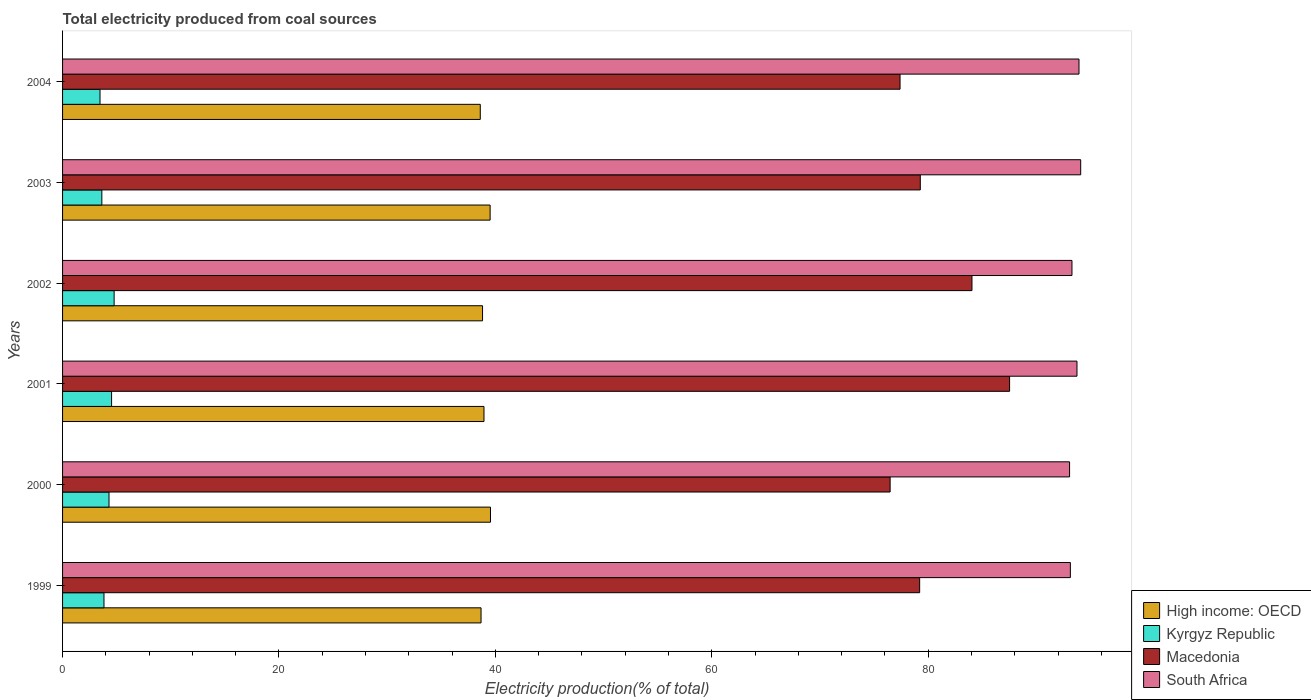Are the number of bars on each tick of the Y-axis equal?
Your response must be concise. Yes. How many bars are there on the 3rd tick from the bottom?
Ensure brevity in your answer.  4. What is the total electricity produced in Macedonia in 2003?
Offer a very short reply. 79.27. Across all years, what is the maximum total electricity produced in South Africa?
Ensure brevity in your answer.  94.09. Across all years, what is the minimum total electricity produced in High income: OECD?
Offer a terse response. 38.6. In which year was the total electricity produced in South Africa minimum?
Your answer should be compact. 2000. What is the total total electricity produced in South Africa in the graph?
Keep it short and to the point. 561.25. What is the difference between the total electricity produced in Kyrgyz Republic in 2000 and that in 2003?
Keep it short and to the point. 0.66. What is the difference between the total electricity produced in Macedonia in 2004 and the total electricity produced in Kyrgyz Republic in 2003?
Offer a terse response. 73.77. What is the average total electricity produced in South Africa per year?
Offer a terse response. 93.54. In the year 1999, what is the difference between the total electricity produced in High income: OECD and total electricity produced in South Africa?
Offer a terse response. -54.46. What is the ratio of the total electricity produced in South Africa in 2000 to that in 2002?
Ensure brevity in your answer.  1. Is the difference between the total electricity produced in High income: OECD in 1999 and 2001 greater than the difference between the total electricity produced in South Africa in 1999 and 2001?
Give a very brief answer. Yes. What is the difference between the highest and the second highest total electricity produced in High income: OECD?
Ensure brevity in your answer.  0.03. What is the difference between the highest and the lowest total electricity produced in Kyrgyz Republic?
Make the answer very short. 1.3. What does the 2nd bar from the top in 2004 represents?
Keep it short and to the point. Macedonia. What does the 2nd bar from the bottom in 1999 represents?
Give a very brief answer. Kyrgyz Republic. Are all the bars in the graph horizontal?
Your answer should be very brief. Yes. How many years are there in the graph?
Offer a terse response. 6. What is the difference between two consecutive major ticks on the X-axis?
Offer a terse response. 20. How many legend labels are there?
Your answer should be very brief. 4. How are the legend labels stacked?
Give a very brief answer. Vertical. What is the title of the graph?
Provide a succinct answer. Total electricity produced from coal sources. Does "Canada" appear as one of the legend labels in the graph?
Your answer should be compact. No. What is the label or title of the Y-axis?
Give a very brief answer. Years. What is the Electricity production(% of total) of High income: OECD in 1999?
Offer a terse response. 38.67. What is the Electricity production(% of total) in Kyrgyz Republic in 1999?
Ensure brevity in your answer.  3.83. What is the Electricity production(% of total) in Macedonia in 1999?
Keep it short and to the point. 79.21. What is the Electricity production(% of total) in South Africa in 1999?
Offer a very short reply. 93.13. What is the Electricity production(% of total) of High income: OECD in 2000?
Give a very brief answer. 39.55. What is the Electricity production(% of total) of Kyrgyz Republic in 2000?
Give a very brief answer. 4.29. What is the Electricity production(% of total) in Macedonia in 2000?
Provide a succinct answer. 76.48. What is the Electricity production(% of total) in South Africa in 2000?
Your answer should be very brief. 93.06. What is the Electricity production(% of total) of High income: OECD in 2001?
Your response must be concise. 38.95. What is the Electricity production(% of total) of Kyrgyz Republic in 2001?
Provide a short and direct response. 4.53. What is the Electricity production(% of total) in Macedonia in 2001?
Your response must be concise. 87.52. What is the Electricity production(% of total) in South Africa in 2001?
Offer a terse response. 93.75. What is the Electricity production(% of total) in High income: OECD in 2002?
Give a very brief answer. 38.81. What is the Electricity production(% of total) of Kyrgyz Republic in 2002?
Your response must be concise. 4.76. What is the Electricity production(% of total) in Macedonia in 2002?
Your answer should be compact. 84.04. What is the Electricity production(% of total) in South Africa in 2002?
Your answer should be compact. 93.28. What is the Electricity production(% of total) in High income: OECD in 2003?
Your answer should be compact. 39.51. What is the Electricity production(% of total) in Kyrgyz Republic in 2003?
Make the answer very short. 3.63. What is the Electricity production(% of total) in Macedonia in 2003?
Provide a short and direct response. 79.27. What is the Electricity production(% of total) in South Africa in 2003?
Provide a short and direct response. 94.09. What is the Electricity production(% of total) of High income: OECD in 2004?
Your answer should be very brief. 38.6. What is the Electricity production(% of total) in Kyrgyz Republic in 2004?
Ensure brevity in your answer.  3.46. What is the Electricity production(% of total) of Macedonia in 2004?
Provide a succinct answer. 77.4. What is the Electricity production(% of total) of South Africa in 2004?
Provide a short and direct response. 93.93. Across all years, what is the maximum Electricity production(% of total) in High income: OECD?
Ensure brevity in your answer.  39.55. Across all years, what is the maximum Electricity production(% of total) of Kyrgyz Republic?
Your answer should be very brief. 4.76. Across all years, what is the maximum Electricity production(% of total) of Macedonia?
Make the answer very short. 87.52. Across all years, what is the maximum Electricity production(% of total) in South Africa?
Give a very brief answer. 94.09. Across all years, what is the minimum Electricity production(% of total) in High income: OECD?
Offer a terse response. 38.6. Across all years, what is the minimum Electricity production(% of total) of Kyrgyz Republic?
Your answer should be compact. 3.46. Across all years, what is the minimum Electricity production(% of total) of Macedonia?
Ensure brevity in your answer.  76.48. Across all years, what is the minimum Electricity production(% of total) in South Africa?
Your answer should be very brief. 93.06. What is the total Electricity production(% of total) in High income: OECD in the graph?
Ensure brevity in your answer.  234.09. What is the total Electricity production(% of total) of Kyrgyz Republic in the graph?
Keep it short and to the point. 24.5. What is the total Electricity production(% of total) in Macedonia in the graph?
Keep it short and to the point. 483.91. What is the total Electricity production(% of total) of South Africa in the graph?
Offer a terse response. 561.25. What is the difference between the Electricity production(% of total) in High income: OECD in 1999 and that in 2000?
Provide a short and direct response. -0.87. What is the difference between the Electricity production(% of total) of Kyrgyz Republic in 1999 and that in 2000?
Your response must be concise. -0.47. What is the difference between the Electricity production(% of total) of Macedonia in 1999 and that in 2000?
Give a very brief answer. 2.73. What is the difference between the Electricity production(% of total) in South Africa in 1999 and that in 2000?
Give a very brief answer. 0.07. What is the difference between the Electricity production(% of total) in High income: OECD in 1999 and that in 2001?
Your response must be concise. -0.27. What is the difference between the Electricity production(% of total) of Kyrgyz Republic in 1999 and that in 2001?
Your answer should be compact. -0.7. What is the difference between the Electricity production(% of total) in Macedonia in 1999 and that in 2001?
Make the answer very short. -8.31. What is the difference between the Electricity production(% of total) in South Africa in 1999 and that in 2001?
Keep it short and to the point. -0.61. What is the difference between the Electricity production(% of total) in High income: OECD in 1999 and that in 2002?
Make the answer very short. -0.14. What is the difference between the Electricity production(% of total) of Kyrgyz Republic in 1999 and that in 2002?
Your answer should be compact. -0.94. What is the difference between the Electricity production(% of total) in Macedonia in 1999 and that in 2002?
Your response must be concise. -4.83. What is the difference between the Electricity production(% of total) in South Africa in 1999 and that in 2002?
Provide a succinct answer. -0.15. What is the difference between the Electricity production(% of total) in High income: OECD in 1999 and that in 2003?
Your answer should be very brief. -0.84. What is the difference between the Electricity production(% of total) in Kyrgyz Republic in 1999 and that in 2003?
Your response must be concise. 0.2. What is the difference between the Electricity production(% of total) in Macedonia in 1999 and that in 2003?
Your answer should be very brief. -0.06. What is the difference between the Electricity production(% of total) of South Africa in 1999 and that in 2003?
Provide a short and direct response. -0.96. What is the difference between the Electricity production(% of total) in High income: OECD in 1999 and that in 2004?
Your answer should be compact. 0.07. What is the difference between the Electricity production(% of total) in Kyrgyz Republic in 1999 and that in 2004?
Your answer should be very brief. 0.37. What is the difference between the Electricity production(% of total) of Macedonia in 1999 and that in 2004?
Your answer should be compact. 1.81. What is the difference between the Electricity production(% of total) in South Africa in 1999 and that in 2004?
Give a very brief answer. -0.8. What is the difference between the Electricity production(% of total) of High income: OECD in 2000 and that in 2001?
Give a very brief answer. 0.6. What is the difference between the Electricity production(% of total) in Kyrgyz Republic in 2000 and that in 2001?
Offer a very short reply. -0.24. What is the difference between the Electricity production(% of total) of Macedonia in 2000 and that in 2001?
Provide a succinct answer. -11.04. What is the difference between the Electricity production(% of total) in South Africa in 2000 and that in 2001?
Provide a succinct answer. -0.68. What is the difference between the Electricity production(% of total) of High income: OECD in 2000 and that in 2002?
Ensure brevity in your answer.  0.73. What is the difference between the Electricity production(% of total) in Kyrgyz Republic in 2000 and that in 2002?
Make the answer very short. -0.47. What is the difference between the Electricity production(% of total) in Macedonia in 2000 and that in 2002?
Keep it short and to the point. -7.56. What is the difference between the Electricity production(% of total) of South Africa in 2000 and that in 2002?
Keep it short and to the point. -0.22. What is the difference between the Electricity production(% of total) in High income: OECD in 2000 and that in 2003?
Give a very brief answer. 0.03. What is the difference between the Electricity production(% of total) in Kyrgyz Republic in 2000 and that in 2003?
Make the answer very short. 0.66. What is the difference between the Electricity production(% of total) in Macedonia in 2000 and that in 2003?
Your response must be concise. -2.79. What is the difference between the Electricity production(% of total) of South Africa in 2000 and that in 2003?
Your answer should be very brief. -1.03. What is the difference between the Electricity production(% of total) of High income: OECD in 2000 and that in 2004?
Provide a succinct answer. 0.94. What is the difference between the Electricity production(% of total) in Kyrgyz Republic in 2000 and that in 2004?
Ensure brevity in your answer.  0.83. What is the difference between the Electricity production(% of total) in Macedonia in 2000 and that in 2004?
Keep it short and to the point. -0.92. What is the difference between the Electricity production(% of total) in South Africa in 2000 and that in 2004?
Your answer should be very brief. -0.87. What is the difference between the Electricity production(% of total) in High income: OECD in 2001 and that in 2002?
Provide a short and direct response. 0.13. What is the difference between the Electricity production(% of total) of Kyrgyz Republic in 2001 and that in 2002?
Make the answer very short. -0.24. What is the difference between the Electricity production(% of total) of Macedonia in 2001 and that in 2002?
Your response must be concise. 3.48. What is the difference between the Electricity production(% of total) in South Africa in 2001 and that in 2002?
Give a very brief answer. 0.46. What is the difference between the Electricity production(% of total) of High income: OECD in 2001 and that in 2003?
Make the answer very short. -0.57. What is the difference between the Electricity production(% of total) in Kyrgyz Republic in 2001 and that in 2003?
Make the answer very short. 0.9. What is the difference between the Electricity production(% of total) in Macedonia in 2001 and that in 2003?
Keep it short and to the point. 8.25. What is the difference between the Electricity production(% of total) in South Africa in 2001 and that in 2003?
Give a very brief answer. -0.34. What is the difference between the Electricity production(% of total) of High income: OECD in 2001 and that in 2004?
Provide a succinct answer. 0.34. What is the difference between the Electricity production(% of total) in Kyrgyz Republic in 2001 and that in 2004?
Your answer should be compact. 1.07. What is the difference between the Electricity production(% of total) in Macedonia in 2001 and that in 2004?
Your answer should be very brief. 10.12. What is the difference between the Electricity production(% of total) in South Africa in 2001 and that in 2004?
Give a very brief answer. -0.19. What is the difference between the Electricity production(% of total) in High income: OECD in 2002 and that in 2003?
Provide a short and direct response. -0.7. What is the difference between the Electricity production(% of total) in Kyrgyz Republic in 2002 and that in 2003?
Keep it short and to the point. 1.13. What is the difference between the Electricity production(% of total) in Macedonia in 2002 and that in 2003?
Offer a terse response. 4.78. What is the difference between the Electricity production(% of total) in South Africa in 2002 and that in 2003?
Make the answer very short. -0.81. What is the difference between the Electricity production(% of total) of High income: OECD in 2002 and that in 2004?
Offer a very short reply. 0.21. What is the difference between the Electricity production(% of total) of Kyrgyz Republic in 2002 and that in 2004?
Provide a short and direct response. 1.3. What is the difference between the Electricity production(% of total) of Macedonia in 2002 and that in 2004?
Keep it short and to the point. 6.65. What is the difference between the Electricity production(% of total) in South Africa in 2002 and that in 2004?
Your answer should be compact. -0.65. What is the difference between the Electricity production(% of total) of High income: OECD in 2003 and that in 2004?
Your answer should be compact. 0.91. What is the difference between the Electricity production(% of total) of Kyrgyz Republic in 2003 and that in 2004?
Provide a succinct answer. 0.17. What is the difference between the Electricity production(% of total) in Macedonia in 2003 and that in 2004?
Your answer should be very brief. 1.87. What is the difference between the Electricity production(% of total) of South Africa in 2003 and that in 2004?
Provide a succinct answer. 0.16. What is the difference between the Electricity production(% of total) in High income: OECD in 1999 and the Electricity production(% of total) in Kyrgyz Republic in 2000?
Your answer should be compact. 34.38. What is the difference between the Electricity production(% of total) in High income: OECD in 1999 and the Electricity production(% of total) in Macedonia in 2000?
Keep it short and to the point. -37.81. What is the difference between the Electricity production(% of total) of High income: OECD in 1999 and the Electricity production(% of total) of South Africa in 2000?
Provide a succinct answer. -54.39. What is the difference between the Electricity production(% of total) in Kyrgyz Republic in 1999 and the Electricity production(% of total) in Macedonia in 2000?
Give a very brief answer. -72.65. What is the difference between the Electricity production(% of total) in Kyrgyz Republic in 1999 and the Electricity production(% of total) in South Africa in 2000?
Offer a very short reply. -89.24. What is the difference between the Electricity production(% of total) of Macedonia in 1999 and the Electricity production(% of total) of South Africa in 2000?
Your answer should be compact. -13.86. What is the difference between the Electricity production(% of total) of High income: OECD in 1999 and the Electricity production(% of total) of Kyrgyz Republic in 2001?
Offer a terse response. 34.14. What is the difference between the Electricity production(% of total) of High income: OECD in 1999 and the Electricity production(% of total) of Macedonia in 2001?
Make the answer very short. -48.85. What is the difference between the Electricity production(% of total) in High income: OECD in 1999 and the Electricity production(% of total) in South Africa in 2001?
Your answer should be very brief. -55.07. What is the difference between the Electricity production(% of total) in Kyrgyz Republic in 1999 and the Electricity production(% of total) in Macedonia in 2001?
Make the answer very short. -83.69. What is the difference between the Electricity production(% of total) of Kyrgyz Republic in 1999 and the Electricity production(% of total) of South Africa in 2001?
Ensure brevity in your answer.  -89.92. What is the difference between the Electricity production(% of total) of Macedonia in 1999 and the Electricity production(% of total) of South Africa in 2001?
Offer a very short reply. -14.54. What is the difference between the Electricity production(% of total) in High income: OECD in 1999 and the Electricity production(% of total) in Kyrgyz Republic in 2002?
Your answer should be compact. 33.91. What is the difference between the Electricity production(% of total) in High income: OECD in 1999 and the Electricity production(% of total) in Macedonia in 2002?
Your response must be concise. -45.37. What is the difference between the Electricity production(% of total) of High income: OECD in 1999 and the Electricity production(% of total) of South Africa in 2002?
Provide a succinct answer. -54.61. What is the difference between the Electricity production(% of total) in Kyrgyz Republic in 1999 and the Electricity production(% of total) in Macedonia in 2002?
Your answer should be very brief. -80.21. What is the difference between the Electricity production(% of total) of Kyrgyz Republic in 1999 and the Electricity production(% of total) of South Africa in 2002?
Offer a very short reply. -89.46. What is the difference between the Electricity production(% of total) in Macedonia in 1999 and the Electricity production(% of total) in South Africa in 2002?
Your answer should be very brief. -14.08. What is the difference between the Electricity production(% of total) of High income: OECD in 1999 and the Electricity production(% of total) of Kyrgyz Republic in 2003?
Your response must be concise. 35.04. What is the difference between the Electricity production(% of total) of High income: OECD in 1999 and the Electricity production(% of total) of Macedonia in 2003?
Ensure brevity in your answer.  -40.59. What is the difference between the Electricity production(% of total) in High income: OECD in 1999 and the Electricity production(% of total) in South Africa in 2003?
Your response must be concise. -55.42. What is the difference between the Electricity production(% of total) in Kyrgyz Republic in 1999 and the Electricity production(% of total) in Macedonia in 2003?
Your answer should be compact. -75.44. What is the difference between the Electricity production(% of total) of Kyrgyz Republic in 1999 and the Electricity production(% of total) of South Africa in 2003?
Your response must be concise. -90.26. What is the difference between the Electricity production(% of total) of Macedonia in 1999 and the Electricity production(% of total) of South Africa in 2003?
Offer a terse response. -14.88. What is the difference between the Electricity production(% of total) in High income: OECD in 1999 and the Electricity production(% of total) in Kyrgyz Republic in 2004?
Make the answer very short. 35.21. What is the difference between the Electricity production(% of total) in High income: OECD in 1999 and the Electricity production(% of total) in Macedonia in 2004?
Provide a short and direct response. -38.72. What is the difference between the Electricity production(% of total) in High income: OECD in 1999 and the Electricity production(% of total) in South Africa in 2004?
Keep it short and to the point. -55.26. What is the difference between the Electricity production(% of total) in Kyrgyz Republic in 1999 and the Electricity production(% of total) in Macedonia in 2004?
Your response must be concise. -73.57. What is the difference between the Electricity production(% of total) of Kyrgyz Republic in 1999 and the Electricity production(% of total) of South Africa in 2004?
Your response must be concise. -90.11. What is the difference between the Electricity production(% of total) in Macedonia in 1999 and the Electricity production(% of total) in South Africa in 2004?
Give a very brief answer. -14.73. What is the difference between the Electricity production(% of total) in High income: OECD in 2000 and the Electricity production(% of total) in Kyrgyz Republic in 2001?
Your response must be concise. 35.02. What is the difference between the Electricity production(% of total) in High income: OECD in 2000 and the Electricity production(% of total) in Macedonia in 2001?
Offer a very short reply. -47.97. What is the difference between the Electricity production(% of total) of High income: OECD in 2000 and the Electricity production(% of total) of South Africa in 2001?
Offer a very short reply. -54.2. What is the difference between the Electricity production(% of total) of Kyrgyz Republic in 2000 and the Electricity production(% of total) of Macedonia in 2001?
Offer a terse response. -83.23. What is the difference between the Electricity production(% of total) of Kyrgyz Republic in 2000 and the Electricity production(% of total) of South Africa in 2001?
Your response must be concise. -89.45. What is the difference between the Electricity production(% of total) of Macedonia in 2000 and the Electricity production(% of total) of South Africa in 2001?
Your answer should be compact. -17.27. What is the difference between the Electricity production(% of total) in High income: OECD in 2000 and the Electricity production(% of total) in Kyrgyz Republic in 2002?
Offer a terse response. 34.78. What is the difference between the Electricity production(% of total) in High income: OECD in 2000 and the Electricity production(% of total) in Macedonia in 2002?
Your answer should be very brief. -44.5. What is the difference between the Electricity production(% of total) in High income: OECD in 2000 and the Electricity production(% of total) in South Africa in 2002?
Your answer should be very brief. -53.74. What is the difference between the Electricity production(% of total) in Kyrgyz Republic in 2000 and the Electricity production(% of total) in Macedonia in 2002?
Ensure brevity in your answer.  -79.75. What is the difference between the Electricity production(% of total) of Kyrgyz Republic in 2000 and the Electricity production(% of total) of South Africa in 2002?
Offer a very short reply. -88.99. What is the difference between the Electricity production(% of total) of Macedonia in 2000 and the Electricity production(% of total) of South Africa in 2002?
Ensure brevity in your answer.  -16.8. What is the difference between the Electricity production(% of total) in High income: OECD in 2000 and the Electricity production(% of total) in Kyrgyz Republic in 2003?
Provide a succinct answer. 35.92. What is the difference between the Electricity production(% of total) in High income: OECD in 2000 and the Electricity production(% of total) in Macedonia in 2003?
Make the answer very short. -39.72. What is the difference between the Electricity production(% of total) in High income: OECD in 2000 and the Electricity production(% of total) in South Africa in 2003?
Your answer should be compact. -54.54. What is the difference between the Electricity production(% of total) in Kyrgyz Republic in 2000 and the Electricity production(% of total) in Macedonia in 2003?
Offer a terse response. -74.97. What is the difference between the Electricity production(% of total) of Kyrgyz Republic in 2000 and the Electricity production(% of total) of South Africa in 2003?
Give a very brief answer. -89.8. What is the difference between the Electricity production(% of total) of Macedonia in 2000 and the Electricity production(% of total) of South Africa in 2003?
Give a very brief answer. -17.61. What is the difference between the Electricity production(% of total) of High income: OECD in 2000 and the Electricity production(% of total) of Kyrgyz Republic in 2004?
Make the answer very short. 36.08. What is the difference between the Electricity production(% of total) in High income: OECD in 2000 and the Electricity production(% of total) in Macedonia in 2004?
Ensure brevity in your answer.  -37.85. What is the difference between the Electricity production(% of total) in High income: OECD in 2000 and the Electricity production(% of total) in South Africa in 2004?
Provide a succinct answer. -54.39. What is the difference between the Electricity production(% of total) of Kyrgyz Republic in 2000 and the Electricity production(% of total) of Macedonia in 2004?
Provide a succinct answer. -73.1. What is the difference between the Electricity production(% of total) in Kyrgyz Republic in 2000 and the Electricity production(% of total) in South Africa in 2004?
Offer a very short reply. -89.64. What is the difference between the Electricity production(% of total) of Macedonia in 2000 and the Electricity production(% of total) of South Africa in 2004?
Your response must be concise. -17.45. What is the difference between the Electricity production(% of total) in High income: OECD in 2001 and the Electricity production(% of total) in Kyrgyz Republic in 2002?
Keep it short and to the point. 34.18. What is the difference between the Electricity production(% of total) in High income: OECD in 2001 and the Electricity production(% of total) in Macedonia in 2002?
Offer a very short reply. -45.1. What is the difference between the Electricity production(% of total) in High income: OECD in 2001 and the Electricity production(% of total) in South Africa in 2002?
Give a very brief answer. -54.34. What is the difference between the Electricity production(% of total) in Kyrgyz Republic in 2001 and the Electricity production(% of total) in Macedonia in 2002?
Provide a succinct answer. -79.51. What is the difference between the Electricity production(% of total) in Kyrgyz Republic in 2001 and the Electricity production(% of total) in South Africa in 2002?
Keep it short and to the point. -88.75. What is the difference between the Electricity production(% of total) of Macedonia in 2001 and the Electricity production(% of total) of South Africa in 2002?
Your answer should be very brief. -5.76. What is the difference between the Electricity production(% of total) of High income: OECD in 2001 and the Electricity production(% of total) of Kyrgyz Republic in 2003?
Provide a succinct answer. 35.32. What is the difference between the Electricity production(% of total) in High income: OECD in 2001 and the Electricity production(% of total) in Macedonia in 2003?
Ensure brevity in your answer.  -40.32. What is the difference between the Electricity production(% of total) of High income: OECD in 2001 and the Electricity production(% of total) of South Africa in 2003?
Offer a terse response. -55.14. What is the difference between the Electricity production(% of total) of Kyrgyz Republic in 2001 and the Electricity production(% of total) of Macedonia in 2003?
Your response must be concise. -74.74. What is the difference between the Electricity production(% of total) in Kyrgyz Republic in 2001 and the Electricity production(% of total) in South Africa in 2003?
Give a very brief answer. -89.56. What is the difference between the Electricity production(% of total) in Macedonia in 2001 and the Electricity production(% of total) in South Africa in 2003?
Ensure brevity in your answer.  -6.57. What is the difference between the Electricity production(% of total) of High income: OECD in 2001 and the Electricity production(% of total) of Kyrgyz Republic in 2004?
Offer a terse response. 35.48. What is the difference between the Electricity production(% of total) in High income: OECD in 2001 and the Electricity production(% of total) in Macedonia in 2004?
Your answer should be very brief. -38.45. What is the difference between the Electricity production(% of total) in High income: OECD in 2001 and the Electricity production(% of total) in South Africa in 2004?
Your answer should be very brief. -54.99. What is the difference between the Electricity production(% of total) in Kyrgyz Republic in 2001 and the Electricity production(% of total) in Macedonia in 2004?
Give a very brief answer. -72.87. What is the difference between the Electricity production(% of total) of Kyrgyz Republic in 2001 and the Electricity production(% of total) of South Africa in 2004?
Give a very brief answer. -89.4. What is the difference between the Electricity production(% of total) in Macedonia in 2001 and the Electricity production(% of total) in South Africa in 2004?
Offer a terse response. -6.41. What is the difference between the Electricity production(% of total) of High income: OECD in 2002 and the Electricity production(% of total) of Kyrgyz Republic in 2003?
Give a very brief answer. 35.18. What is the difference between the Electricity production(% of total) in High income: OECD in 2002 and the Electricity production(% of total) in Macedonia in 2003?
Your answer should be very brief. -40.45. What is the difference between the Electricity production(% of total) of High income: OECD in 2002 and the Electricity production(% of total) of South Africa in 2003?
Provide a succinct answer. -55.28. What is the difference between the Electricity production(% of total) in Kyrgyz Republic in 2002 and the Electricity production(% of total) in Macedonia in 2003?
Your answer should be very brief. -74.5. What is the difference between the Electricity production(% of total) in Kyrgyz Republic in 2002 and the Electricity production(% of total) in South Africa in 2003?
Offer a very short reply. -89.33. What is the difference between the Electricity production(% of total) of Macedonia in 2002 and the Electricity production(% of total) of South Africa in 2003?
Keep it short and to the point. -10.05. What is the difference between the Electricity production(% of total) of High income: OECD in 2002 and the Electricity production(% of total) of Kyrgyz Republic in 2004?
Provide a short and direct response. 35.35. What is the difference between the Electricity production(% of total) in High income: OECD in 2002 and the Electricity production(% of total) in Macedonia in 2004?
Make the answer very short. -38.58. What is the difference between the Electricity production(% of total) of High income: OECD in 2002 and the Electricity production(% of total) of South Africa in 2004?
Provide a succinct answer. -55.12. What is the difference between the Electricity production(% of total) in Kyrgyz Republic in 2002 and the Electricity production(% of total) in Macedonia in 2004?
Offer a very short reply. -72.63. What is the difference between the Electricity production(% of total) in Kyrgyz Republic in 2002 and the Electricity production(% of total) in South Africa in 2004?
Offer a very short reply. -89.17. What is the difference between the Electricity production(% of total) of Macedonia in 2002 and the Electricity production(% of total) of South Africa in 2004?
Offer a terse response. -9.89. What is the difference between the Electricity production(% of total) in High income: OECD in 2003 and the Electricity production(% of total) in Kyrgyz Republic in 2004?
Provide a short and direct response. 36.05. What is the difference between the Electricity production(% of total) of High income: OECD in 2003 and the Electricity production(% of total) of Macedonia in 2004?
Provide a short and direct response. -37.88. What is the difference between the Electricity production(% of total) of High income: OECD in 2003 and the Electricity production(% of total) of South Africa in 2004?
Provide a short and direct response. -54.42. What is the difference between the Electricity production(% of total) in Kyrgyz Republic in 2003 and the Electricity production(% of total) in Macedonia in 2004?
Your answer should be compact. -73.77. What is the difference between the Electricity production(% of total) in Kyrgyz Republic in 2003 and the Electricity production(% of total) in South Africa in 2004?
Your answer should be compact. -90.3. What is the difference between the Electricity production(% of total) in Macedonia in 2003 and the Electricity production(% of total) in South Africa in 2004?
Give a very brief answer. -14.67. What is the average Electricity production(% of total) of High income: OECD per year?
Make the answer very short. 39.02. What is the average Electricity production(% of total) in Kyrgyz Republic per year?
Offer a very short reply. 4.08. What is the average Electricity production(% of total) of Macedonia per year?
Provide a short and direct response. 80.65. What is the average Electricity production(% of total) of South Africa per year?
Offer a very short reply. 93.54. In the year 1999, what is the difference between the Electricity production(% of total) in High income: OECD and Electricity production(% of total) in Kyrgyz Republic?
Your answer should be very brief. 34.85. In the year 1999, what is the difference between the Electricity production(% of total) in High income: OECD and Electricity production(% of total) in Macedonia?
Keep it short and to the point. -40.53. In the year 1999, what is the difference between the Electricity production(% of total) in High income: OECD and Electricity production(% of total) in South Africa?
Give a very brief answer. -54.46. In the year 1999, what is the difference between the Electricity production(% of total) in Kyrgyz Republic and Electricity production(% of total) in Macedonia?
Offer a terse response. -75.38. In the year 1999, what is the difference between the Electricity production(% of total) of Kyrgyz Republic and Electricity production(% of total) of South Africa?
Your answer should be very brief. -89.31. In the year 1999, what is the difference between the Electricity production(% of total) of Macedonia and Electricity production(% of total) of South Africa?
Keep it short and to the point. -13.93. In the year 2000, what is the difference between the Electricity production(% of total) of High income: OECD and Electricity production(% of total) of Kyrgyz Republic?
Your response must be concise. 35.25. In the year 2000, what is the difference between the Electricity production(% of total) in High income: OECD and Electricity production(% of total) in Macedonia?
Provide a succinct answer. -36.93. In the year 2000, what is the difference between the Electricity production(% of total) of High income: OECD and Electricity production(% of total) of South Africa?
Your answer should be compact. -53.52. In the year 2000, what is the difference between the Electricity production(% of total) in Kyrgyz Republic and Electricity production(% of total) in Macedonia?
Provide a succinct answer. -72.19. In the year 2000, what is the difference between the Electricity production(% of total) of Kyrgyz Republic and Electricity production(% of total) of South Africa?
Offer a terse response. -88.77. In the year 2000, what is the difference between the Electricity production(% of total) of Macedonia and Electricity production(% of total) of South Africa?
Provide a short and direct response. -16.58. In the year 2001, what is the difference between the Electricity production(% of total) in High income: OECD and Electricity production(% of total) in Kyrgyz Republic?
Ensure brevity in your answer.  34.42. In the year 2001, what is the difference between the Electricity production(% of total) in High income: OECD and Electricity production(% of total) in Macedonia?
Ensure brevity in your answer.  -48.57. In the year 2001, what is the difference between the Electricity production(% of total) of High income: OECD and Electricity production(% of total) of South Africa?
Your answer should be very brief. -54.8. In the year 2001, what is the difference between the Electricity production(% of total) in Kyrgyz Republic and Electricity production(% of total) in Macedonia?
Offer a terse response. -82.99. In the year 2001, what is the difference between the Electricity production(% of total) in Kyrgyz Republic and Electricity production(% of total) in South Africa?
Provide a short and direct response. -89.22. In the year 2001, what is the difference between the Electricity production(% of total) in Macedonia and Electricity production(% of total) in South Africa?
Your answer should be very brief. -6.23. In the year 2002, what is the difference between the Electricity production(% of total) in High income: OECD and Electricity production(% of total) in Kyrgyz Republic?
Provide a succinct answer. 34.05. In the year 2002, what is the difference between the Electricity production(% of total) in High income: OECD and Electricity production(% of total) in Macedonia?
Provide a succinct answer. -45.23. In the year 2002, what is the difference between the Electricity production(% of total) in High income: OECD and Electricity production(% of total) in South Africa?
Offer a very short reply. -54.47. In the year 2002, what is the difference between the Electricity production(% of total) of Kyrgyz Republic and Electricity production(% of total) of Macedonia?
Your response must be concise. -79.28. In the year 2002, what is the difference between the Electricity production(% of total) in Kyrgyz Republic and Electricity production(% of total) in South Africa?
Ensure brevity in your answer.  -88.52. In the year 2002, what is the difference between the Electricity production(% of total) in Macedonia and Electricity production(% of total) in South Africa?
Provide a short and direct response. -9.24. In the year 2003, what is the difference between the Electricity production(% of total) in High income: OECD and Electricity production(% of total) in Kyrgyz Republic?
Your answer should be very brief. 35.88. In the year 2003, what is the difference between the Electricity production(% of total) in High income: OECD and Electricity production(% of total) in Macedonia?
Provide a succinct answer. -39.75. In the year 2003, what is the difference between the Electricity production(% of total) of High income: OECD and Electricity production(% of total) of South Africa?
Your response must be concise. -54.58. In the year 2003, what is the difference between the Electricity production(% of total) in Kyrgyz Republic and Electricity production(% of total) in Macedonia?
Your answer should be very brief. -75.64. In the year 2003, what is the difference between the Electricity production(% of total) in Kyrgyz Republic and Electricity production(% of total) in South Africa?
Your answer should be compact. -90.46. In the year 2003, what is the difference between the Electricity production(% of total) in Macedonia and Electricity production(% of total) in South Africa?
Keep it short and to the point. -14.82. In the year 2004, what is the difference between the Electricity production(% of total) in High income: OECD and Electricity production(% of total) in Kyrgyz Republic?
Keep it short and to the point. 35.14. In the year 2004, what is the difference between the Electricity production(% of total) in High income: OECD and Electricity production(% of total) in Macedonia?
Your answer should be very brief. -38.79. In the year 2004, what is the difference between the Electricity production(% of total) of High income: OECD and Electricity production(% of total) of South Africa?
Ensure brevity in your answer.  -55.33. In the year 2004, what is the difference between the Electricity production(% of total) of Kyrgyz Republic and Electricity production(% of total) of Macedonia?
Make the answer very short. -73.94. In the year 2004, what is the difference between the Electricity production(% of total) in Kyrgyz Republic and Electricity production(% of total) in South Africa?
Offer a terse response. -90.47. In the year 2004, what is the difference between the Electricity production(% of total) of Macedonia and Electricity production(% of total) of South Africa?
Make the answer very short. -16.54. What is the ratio of the Electricity production(% of total) of Kyrgyz Republic in 1999 to that in 2000?
Your response must be concise. 0.89. What is the ratio of the Electricity production(% of total) of Macedonia in 1999 to that in 2000?
Your answer should be compact. 1.04. What is the ratio of the Electricity production(% of total) in South Africa in 1999 to that in 2000?
Your answer should be very brief. 1. What is the ratio of the Electricity production(% of total) in Kyrgyz Republic in 1999 to that in 2001?
Provide a succinct answer. 0.85. What is the ratio of the Electricity production(% of total) in Macedonia in 1999 to that in 2001?
Provide a succinct answer. 0.91. What is the ratio of the Electricity production(% of total) of South Africa in 1999 to that in 2001?
Provide a succinct answer. 0.99. What is the ratio of the Electricity production(% of total) of Kyrgyz Republic in 1999 to that in 2002?
Offer a terse response. 0.8. What is the ratio of the Electricity production(% of total) of Macedonia in 1999 to that in 2002?
Provide a short and direct response. 0.94. What is the ratio of the Electricity production(% of total) of High income: OECD in 1999 to that in 2003?
Provide a short and direct response. 0.98. What is the ratio of the Electricity production(% of total) in Kyrgyz Republic in 1999 to that in 2003?
Offer a very short reply. 1.05. What is the ratio of the Electricity production(% of total) in Kyrgyz Republic in 1999 to that in 2004?
Your answer should be very brief. 1.11. What is the ratio of the Electricity production(% of total) in Macedonia in 1999 to that in 2004?
Offer a terse response. 1.02. What is the ratio of the Electricity production(% of total) of South Africa in 1999 to that in 2004?
Keep it short and to the point. 0.99. What is the ratio of the Electricity production(% of total) of High income: OECD in 2000 to that in 2001?
Offer a terse response. 1.02. What is the ratio of the Electricity production(% of total) of Kyrgyz Republic in 2000 to that in 2001?
Give a very brief answer. 0.95. What is the ratio of the Electricity production(% of total) of Macedonia in 2000 to that in 2001?
Provide a short and direct response. 0.87. What is the ratio of the Electricity production(% of total) in High income: OECD in 2000 to that in 2002?
Make the answer very short. 1.02. What is the ratio of the Electricity production(% of total) in Kyrgyz Republic in 2000 to that in 2002?
Keep it short and to the point. 0.9. What is the ratio of the Electricity production(% of total) of Macedonia in 2000 to that in 2002?
Your answer should be compact. 0.91. What is the ratio of the Electricity production(% of total) in High income: OECD in 2000 to that in 2003?
Ensure brevity in your answer.  1. What is the ratio of the Electricity production(% of total) in Kyrgyz Republic in 2000 to that in 2003?
Provide a succinct answer. 1.18. What is the ratio of the Electricity production(% of total) of Macedonia in 2000 to that in 2003?
Give a very brief answer. 0.96. What is the ratio of the Electricity production(% of total) in High income: OECD in 2000 to that in 2004?
Ensure brevity in your answer.  1.02. What is the ratio of the Electricity production(% of total) of Kyrgyz Republic in 2000 to that in 2004?
Your answer should be very brief. 1.24. What is the ratio of the Electricity production(% of total) in South Africa in 2000 to that in 2004?
Give a very brief answer. 0.99. What is the ratio of the Electricity production(% of total) in High income: OECD in 2001 to that in 2002?
Provide a succinct answer. 1. What is the ratio of the Electricity production(% of total) of Kyrgyz Republic in 2001 to that in 2002?
Your response must be concise. 0.95. What is the ratio of the Electricity production(% of total) in Macedonia in 2001 to that in 2002?
Your response must be concise. 1.04. What is the ratio of the Electricity production(% of total) in South Africa in 2001 to that in 2002?
Keep it short and to the point. 1. What is the ratio of the Electricity production(% of total) in High income: OECD in 2001 to that in 2003?
Provide a succinct answer. 0.99. What is the ratio of the Electricity production(% of total) in Kyrgyz Republic in 2001 to that in 2003?
Your answer should be very brief. 1.25. What is the ratio of the Electricity production(% of total) in Macedonia in 2001 to that in 2003?
Offer a terse response. 1.1. What is the ratio of the Electricity production(% of total) in South Africa in 2001 to that in 2003?
Your response must be concise. 1. What is the ratio of the Electricity production(% of total) of High income: OECD in 2001 to that in 2004?
Your answer should be very brief. 1.01. What is the ratio of the Electricity production(% of total) in Kyrgyz Republic in 2001 to that in 2004?
Ensure brevity in your answer.  1.31. What is the ratio of the Electricity production(% of total) of Macedonia in 2001 to that in 2004?
Provide a short and direct response. 1.13. What is the ratio of the Electricity production(% of total) of South Africa in 2001 to that in 2004?
Provide a succinct answer. 1. What is the ratio of the Electricity production(% of total) in High income: OECD in 2002 to that in 2003?
Provide a short and direct response. 0.98. What is the ratio of the Electricity production(% of total) of Kyrgyz Republic in 2002 to that in 2003?
Give a very brief answer. 1.31. What is the ratio of the Electricity production(% of total) of Macedonia in 2002 to that in 2003?
Your answer should be very brief. 1.06. What is the ratio of the Electricity production(% of total) of High income: OECD in 2002 to that in 2004?
Ensure brevity in your answer.  1.01. What is the ratio of the Electricity production(% of total) of Kyrgyz Republic in 2002 to that in 2004?
Ensure brevity in your answer.  1.38. What is the ratio of the Electricity production(% of total) in Macedonia in 2002 to that in 2004?
Make the answer very short. 1.09. What is the ratio of the Electricity production(% of total) of South Africa in 2002 to that in 2004?
Make the answer very short. 0.99. What is the ratio of the Electricity production(% of total) of High income: OECD in 2003 to that in 2004?
Make the answer very short. 1.02. What is the ratio of the Electricity production(% of total) in Kyrgyz Republic in 2003 to that in 2004?
Your answer should be compact. 1.05. What is the ratio of the Electricity production(% of total) in Macedonia in 2003 to that in 2004?
Your answer should be very brief. 1.02. What is the difference between the highest and the second highest Electricity production(% of total) in High income: OECD?
Offer a terse response. 0.03. What is the difference between the highest and the second highest Electricity production(% of total) of Kyrgyz Republic?
Make the answer very short. 0.24. What is the difference between the highest and the second highest Electricity production(% of total) of Macedonia?
Make the answer very short. 3.48. What is the difference between the highest and the second highest Electricity production(% of total) in South Africa?
Your answer should be compact. 0.16. What is the difference between the highest and the lowest Electricity production(% of total) in High income: OECD?
Your answer should be very brief. 0.94. What is the difference between the highest and the lowest Electricity production(% of total) of Kyrgyz Republic?
Give a very brief answer. 1.3. What is the difference between the highest and the lowest Electricity production(% of total) in Macedonia?
Make the answer very short. 11.04. What is the difference between the highest and the lowest Electricity production(% of total) of South Africa?
Give a very brief answer. 1.03. 